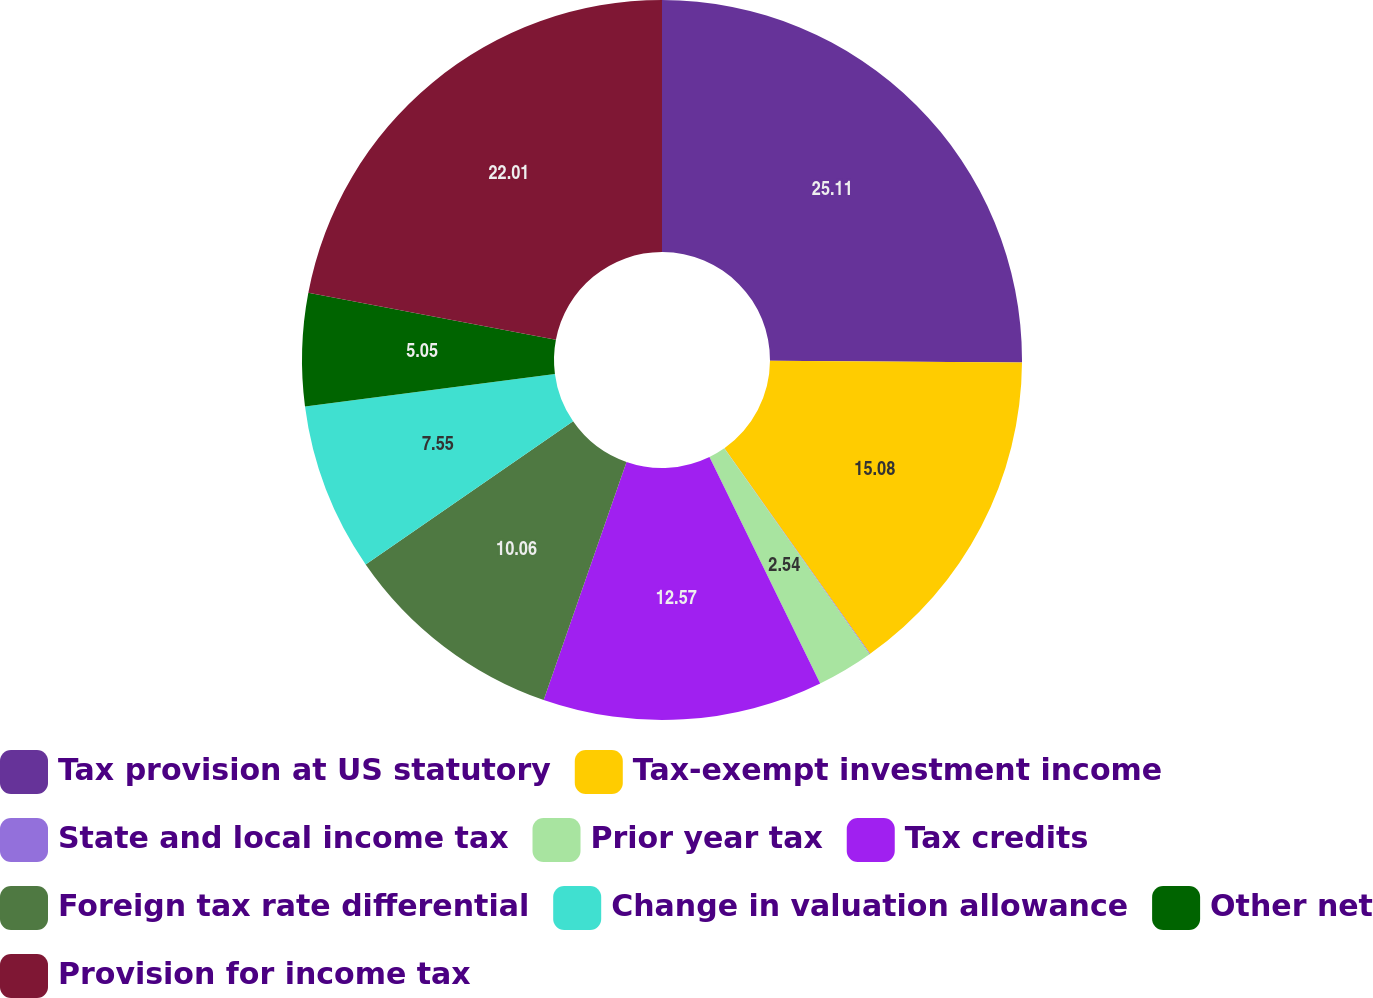Convert chart. <chart><loc_0><loc_0><loc_500><loc_500><pie_chart><fcel>Tax provision at US statutory<fcel>Tax-exempt investment income<fcel>State and local income tax<fcel>Prior year tax<fcel>Tax credits<fcel>Foreign tax rate differential<fcel>Change in valuation allowance<fcel>Other net<fcel>Provision for income tax<nl><fcel>25.11%<fcel>15.08%<fcel>0.03%<fcel>2.54%<fcel>12.57%<fcel>10.06%<fcel>7.55%<fcel>5.05%<fcel>22.01%<nl></chart> 